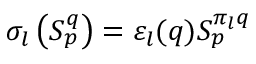Convert formula to latex. <formula><loc_0><loc_0><loc_500><loc_500>\sigma _ { l } \left ( S _ { p } ^ { q } \right ) = \varepsilon _ { l } ( q ) S _ { p } ^ { \pi _ { l } q }</formula> 